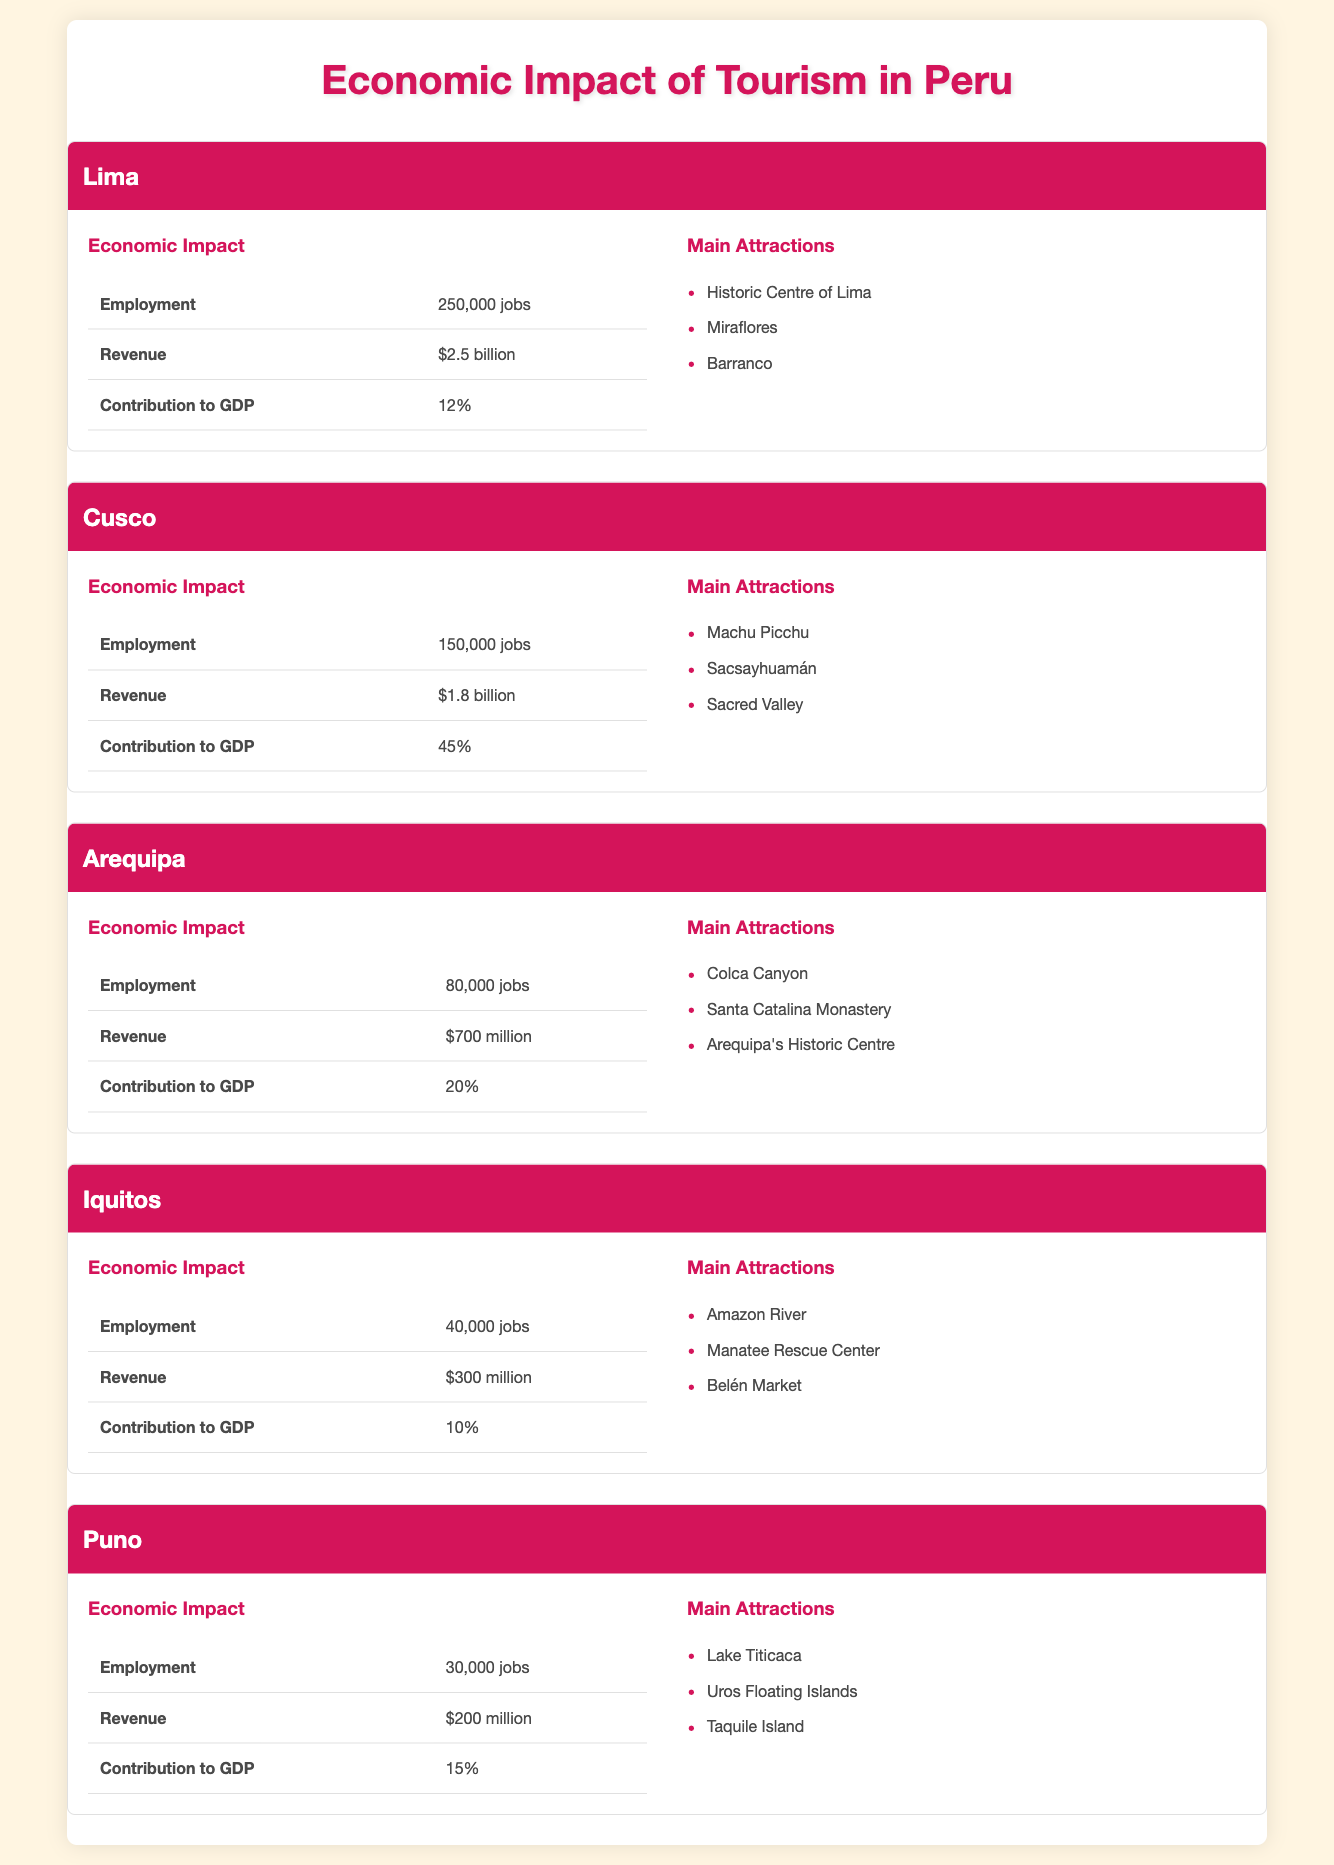What is the employment impact of tourism in Lima? The table lists the employment impact under the "Economic Impact" section for Lima, which states it is "250,000 jobs".
Answer: 250,000 jobs Which region has the highest contribution to GDP from tourism? By examining the "Contribution to GDP" values for each region, Cusco shows a contribution of "45%", which is the highest among the regions listed.
Answer: Cusco How much revenue does Arequipa generate from tourism compared to Iquitos? The revenue for Arequipa is "$700 million" and for Iquitos is "$300 million". Comparing these amounts shows that Arequipa generates more revenue than Iquitos by subtracting: 700 - 300 = 400, which means Arequipa generates $400 million more.
Answer: Arequipa generates $400 million more Does Iquitos have a higher revenue impact than Puno? The revenue for Iquitos is "$300 million" and for Puno it is "$200 million". Since 300 is greater than 200, this indicates that Iquitos has a higher revenue impact than Puno.
Answer: Yes What is the total employment impact of tourism across all listed regions? To find the total employment, we add the jobs from each region: 250,000 (Lima) + 150,000 (Cusco) + 80,000 (Arequipa) + 40,000 (Iquitos) + 30,000 (Puno) = 550,000 jobs total.
Answer: 550,000 jobs 